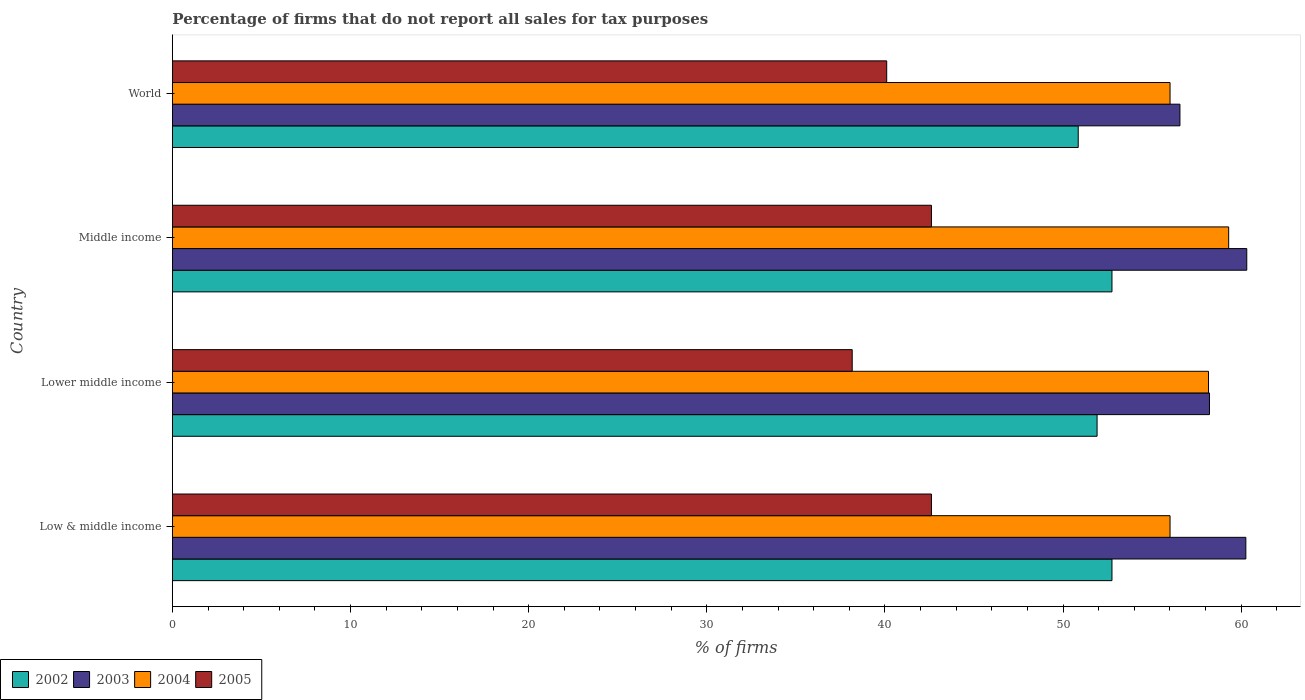How many groups of bars are there?
Offer a terse response. 4. Are the number of bars per tick equal to the number of legend labels?
Provide a short and direct response. Yes. Are the number of bars on each tick of the Y-axis equal?
Provide a short and direct response. Yes. What is the percentage of firms that do not report all sales for tax purposes in 2002 in Low & middle income?
Provide a succinct answer. 52.75. Across all countries, what is the maximum percentage of firms that do not report all sales for tax purposes in 2004?
Ensure brevity in your answer.  59.3. Across all countries, what is the minimum percentage of firms that do not report all sales for tax purposes in 2005?
Keep it short and to the point. 38.16. In which country was the percentage of firms that do not report all sales for tax purposes in 2002 maximum?
Offer a very short reply. Low & middle income. In which country was the percentage of firms that do not report all sales for tax purposes in 2003 minimum?
Give a very brief answer. World. What is the total percentage of firms that do not report all sales for tax purposes in 2002 in the graph?
Your answer should be very brief. 208.25. What is the difference between the percentage of firms that do not report all sales for tax purposes in 2005 in Middle income and that in World?
Your answer should be compact. 2.51. What is the difference between the percentage of firms that do not report all sales for tax purposes in 2003 in Middle income and the percentage of firms that do not report all sales for tax purposes in 2005 in World?
Ensure brevity in your answer.  20.21. What is the average percentage of firms that do not report all sales for tax purposes in 2003 per country?
Ensure brevity in your answer.  58.84. What is the difference between the percentage of firms that do not report all sales for tax purposes in 2003 and percentage of firms that do not report all sales for tax purposes in 2004 in World?
Offer a terse response. 0.55. What is the ratio of the percentage of firms that do not report all sales for tax purposes in 2004 in Low & middle income to that in Middle income?
Make the answer very short. 0.94. Is the difference between the percentage of firms that do not report all sales for tax purposes in 2003 in Low & middle income and Lower middle income greater than the difference between the percentage of firms that do not report all sales for tax purposes in 2004 in Low & middle income and Lower middle income?
Keep it short and to the point. Yes. What is the difference between the highest and the second highest percentage of firms that do not report all sales for tax purposes in 2003?
Provide a short and direct response. 0.05. What is the difference between the highest and the lowest percentage of firms that do not report all sales for tax purposes in 2003?
Provide a succinct answer. 3.75. Are all the bars in the graph horizontal?
Your answer should be compact. Yes. Are the values on the major ticks of X-axis written in scientific E-notation?
Your answer should be very brief. No. Does the graph contain grids?
Make the answer very short. No. Where does the legend appear in the graph?
Offer a very short reply. Bottom left. How are the legend labels stacked?
Provide a short and direct response. Horizontal. What is the title of the graph?
Offer a terse response. Percentage of firms that do not report all sales for tax purposes. What is the label or title of the X-axis?
Your response must be concise. % of firms. What is the % of firms of 2002 in Low & middle income?
Your answer should be compact. 52.75. What is the % of firms of 2003 in Low & middle income?
Ensure brevity in your answer.  60.26. What is the % of firms in 2004 in Low & middle income?
Your answer should be compact. 56.01. What is the % of firms in 2005 in Low & middle income?
Your answer should be compact. 42.61. What is the % of firms in 2002 in Lower middle income?
Your response must be concise. 51.91. What is the % of firms in 2003 in Lower middle income?
Provide a succinct answer. 58.22. What is the % of firms in 2004 in Lower middle income?
Your answer should be very brief. 58.16. What is the % of firms in 2005 in Lower middle income?
Offer a terse response. 38.16. What is the % of firms of 2002 in Middle income?
Your answer should be compact. 52.75. What is the % of firms of 2003 in Middle income?
Provide a short and direct response. 60.31. What is the % of firms in 2004 in Middle income?
Keep it short and to the point. 59.3. What is the % of firms in 2005 in Middle income?
Offer a terse response. 42.61. What is the % of firms in 2002 in World?
Offer a very short reply. 50.85. What is the % of firms of 2003 in World?
Offer a terse response. 56.56. What is the % of firms of 2004 in World?
Your response must be concise. 56.01. What is the % of firms of 2005 in World?
Your answer should be very brief. 40.1. Across all countries, what is the maximum % of firms of 2002?
Your answer should be very brief. 52.75. Across all countries, what is the maximum % of firms in 2003?
Your response must be concise. 60.31. Across all countries, what is the maximum % of firms of 2004?
Provide a succinct answer. 59.3. Across all countries, what is the maximum % of firms in 2005?
Ensure brevity in your answer.  42.61. Across all countries, what is the minimum % of firms in 2002?
Provide a short and direct response. 50.85. Across all countries, what is the minimum % of firms of 2003?
Your answer should be compact. 56.56. Across all countries, what is the minimum % of firms of 2004?
Offer a terse response. 56.01. Across all countries, what is the minimum % of firms of 2005?
Provide a short and direct response. 38.16. What is the total % of firms in 2002 in the graph?
Provide a short and direct response. 208.25. What is the total % of firms in 2003 in the graph?
Give a very brief answer. 235.35. What is the total % of firms of 2004 in the graph?
Provide a succinct answer. 229.47. What is the total % of firms in 2005 in the graph?
Your answer should be very brief. 163.48. What is the difference between the % of firms of 2002 in Low & middle income and that in Lower middle income?
Your response must be concise. 0.84. What is the difference between the % of firms of 2003 in Low & middle income and that in Lower middle income?
Ensure brevity in your answer.  2.04. What is the difference between the % of firms in 2004 in Low & middle income and that in Lower middle income?
Keep it short and to the point. -2.16. What is the difference between the % of firms in 2005 in Low & middle income and that in Lower middle income?
Ensure brevity in your answer.  4.45. What is the difference between the % of firms in 2003 in Low & middle income and that in Middle income?
Your answer should be compact. -0.05. What is the difference between the % of firms of 2004 in Low & middle income and that in Middle income?
Keep it short and to the point. -3.29. What is the difference between the % of firms of 2005 in Low & middle income and that in Middle income?
Your answer should be compact. 0. What is the difference between the % of firms in 2002 in Low & middle income and that in World?
Offer a very short reply. 1.89. What is the difference between the % of firms of 2003 in Low & middle income and that in World?
Keep it short and to the point. 3.7. What is the difference between the % of firms of 2004 in Low & middle income and that in World?
Offer a terse response. 0. What is the difference between the % of firms of 2005 in Low & middle income and that in World?
Your response must be concise. 2.51. What is the difference between the % of firms of 2002 in Lower middle income and that in Middle income?
Your response must be concise. -0.84. What is the difference between the % of firms of 2003 in Lower middle income and that in Middle income?
Offer a very short reply. -2.09. What is the difference between the % of firms of 2004 in Lower middle income and that in Middle income?
Provide a succinct answer. -1.13. What is the difference between the % of firms in 2005 in Lower middle income and that in Middle income?
Provide a short and direct response. -4.45. What is the difference between the % of firms of 2002 in Lower middle income and that in World?
Give a very brief answer. 1.06. What is the difference between the % of firms in 2003 in Lower middle income and that in World?
Give a very brief answer. 1.66. What is the difference between the % of firms in 2004 in Lower middle income and that in World?
Ensure brevity in your answer.  2.16. What is the difference between the % of firms in 2005 in Lower middle income and that in World?
Offer a terse response. -1.94. What is the difference between the % of firms of 2002 in Middle income and that in World?
Provide a short and direct response. 1.89. What is the difference between the % of firms of 2003 in Middle income and that in World?
Make the answer very short. 3.75. What is the difference between the % of firms of 2004 in Middle income and that in World?
Provide a short and direct response. 3.29. What is the difference between the % of firms in 2005 in Middle income and that in World?
Keep it short and to the point. 2.51. What is the difference between the % of firms of 2002 in Low & middle income and the % of firms of 2003 in Lower middle income?
Your response must be concise. -5.47. What is the difference between the % of firms in 2002 in Low & middle income and the % of firms in 2004 in Lower middle income?
Provide a succinct answer. -5.42. What is the difference between the % of firms in 2002 in Low & middle income and the % of firms in 2005 in Lower middle income?
Provide a short and direct response. 14.58. What is the difference between the % of firms in 2003 in Low & middle income and the % of firms in 2004 in Lower middle income?
Offer a very short reply. 2.1. What is the difference between the % of firms of 2003 in Low & middle income and the % of firms of 2005 in Lower middle income?
Offer a terse response. 22.1. What is the difference between the % of firms in 2004 in Low & middle income and the % of firms in 2005 in Lower middle income?
Provide a succinct answer. 17.84. What is the difference between the % of firms in 2002 in Low & middle income and the % of firms in 2003 in Middle income?
Keep it short and to the point. -7.57. What is the difference between the % of firms of 2002 in Low & middle income and the % of firms of 2004 in Middle income?
Keep it short and to the point. -6.55. What is the difference between the % of firms in 2002 in Low & middle income and the % of firms in 2005 in Middle income?
Offer a terse response. 10.13. What is the difference between the % of firms of 2003 in Low & middle income and the % of firms of 2005 in Middle income?
Ensure brevity in your answer.  17.65. What is the difference between the % of firms of 2004 in Low & middle income and the % of firms of 2005 in Middle income?
Your answer should be very brief. 13.39. What is the difference between the % of firms in 2002 in Low & middle income and the % of firms in 2003 in World?
Make the answer very short. -3.81. What is the difference between the % of firms in 2002 in Low & middle income and the % of firms in 2004 in World?
Provide a short and direct response. -3.26. What is the difference between the % of firms in 2002 in Low & middle income and the % of firms in 2005 in World?
Give a very brief answer. 12.65. What is the difference between the % of firms in 2003 in Low & middle income and the % of firms in 2004 in World?
Give a very brief answer. 4.25. What is the difference between the % of firms of 2003 in Low & middle income and the % of firms of 2005 in World?
Ensure brevity in your answer.  20.16. What is the difference between the % of firms of 2004 in Low & middle income and the % of firms of 2005 in World?
Ensure brevity in your answer.  15.91. What is the difference between the % of firms of 2002 in Lower middle income and the % of firms of 2003 in Middle income?
Keep it short and to the point. -8.4. What is the difference between the % of firms of 2002 in Lower middle income and the % of firms of 2004 in Middle income?
Provide a short and direct response. -7.39. What is the difference between the % of firms of 2002 in Lower middle income and the % of firms of 2005 in Middle income?
Provide a short and direct response. 9.3. What is the difference between the % of firms in 2003 in Lower middle income and the % of firms in 2004 in Middle income?
Keep it short and to the point. -1.08. What is the difference between the % of firms of 2003 in Lower middle income and the % of firms of 2005 in Middle income?
Offer a terse response. 15.61. What is the difference between the % of firms in 2004 in Lower middle income and the % of firms in 2005 in Middle income?
Offer a very short reply. 15.55. What is the difference between the % of firms in 2002 in Lower middle income and the % of firms in 2003 in World?
Provide a short and direct response. -4.65. What is the difference between the % of firms of 2002 in Lower middle income and the % of firms of 2004 in World?
Offer a very short reply. -4.1. What is the difference between the % of firms in 2002 in Lower middle income and the % of firms in 2005 in World?
Make the answer very short. 11.81. What is the difference between the % of firms of 2003 in Lower middle income and the % of firms of 2004 in World?
Provide a succinct answer. 2.21. What is the difference between the % of firms in 2003 in Lower middle income and the % of firms in 2005 in World?
Your answer should be very brief. 18.12. What is the difference between the % of firms in 2004 in Lower middle income and the % of firms in 2005 in World?
Offer a very short reply. 18.07. What is the difference between the % of firms of 2002 in Middle income and the % of firms of 2003 in World?
Offer a very short reply. -3.81. What is the difference between the % of firms of 2002 in Middle income and the % of firms of 2004 in World?
Your response must be concise. -3.26. What is the difference between the % of firms in 2002 in Middle income and the % of firms in 2005 in World?
Keep it short and to the point. 12.65. What is the difference between the % of firms of 2003 in Middle income and the % of firms of 2004 in World?
Your answer should be very brief. 4.31. What is the difference between the % of firms in 2003 in Middle income and the % of firms in 2005 in World?
Give a very brief answer. 20.21. What is the difference between the % of firms of 2004 in Middle income and the % of firms of 2005 in World?
Keep it short and to the point. 19.2. What is the average % of firms of 2002 per country?
Your response must be concise. 52.06. What is the average % of firms of 2003 per country?
Provide a succinct answer. 58.84. What is the average % of firms of 2004 per country?
Give a very brief answer. 57.37. What is the average % of firms in 2005 per country?
Give a very brief answer. 40.87. What is the difference between the % of firms of 2002 and % of firms of 2003 in Low & middle income?
Offer a very short reply. -7.51. What is the difference between the % of firms of 2002 and % of firms of 2004 in Low & middle income?
Offer a very short reply. -3.26. What is the difference between the % of firms of 2002 and % of firms of 2005 in Low & middle income?
Provide a short and direct response. 10.13. What is the difference between the % of firms of 2003 and % of firms of 2004 in Low & middle income?
Make the answer very short. 4.25. What is the difference between the % of firms in 2003 and % of firms in 2005 in Low & middle income?
Make the answer very short. 17.65. What is the difference between the % of firms in 2004 and % of firms in 2005 in Low & middle income?
Provide a short and direct response. 13.39. What is the difference between the % of firms of 2002 and % of firms of 2003 in Lower middle income?
Give a very brief answer. -6.31. What is the difference between the % of firms in 2002 and % of firms in 2004 in Lower middle income?
Your response must be concise. -6.26. What is the difference between the % of firms in 2002 and % of firms in 2005 in Lower middle income?
Your answer should be compact. 13.75. What is the difference between the % of firms in 2003 and % of firms in 2004 in Lower middle income?
Make the answer very short. 0.05. What is the difference between the % of firms of 2003 and % of firms of 2005 in Lower middle income?
Provide a short and direct response. 20.06. What is the difference between the % of firms in 2004 and % of firms in 2005 in Lower middle income?
Make the answer very short. 20. What is the difference between the % of firms of 2002 and % of firms of 2003 in Middle income?
Offer a terse response. -7.57. What is the difference between the % of firms of 2002 and % of firms of 2004 in Middle income?
Ensure brevity in your answer.  -6.55. What is the difference between the % of firms in 2002 and % of firms in 2005 in Middle income?
Provide a succinct answer. 10.13. What is the difference between the % of firms of 2003 and % of firms of 2004 in Middle income?
Provide a short and direct response. 1.02. What is the difference between the % of firms in 2003 and % of firms in 2005 in Middle income?
Your response must be concise. 17.7. What is the difference between the % of firms of 2004 and % of firms of 2005 in Middle income?
Offer a very short reply. 16.69. What is the difference between the % of firms in 2002 and % of firms in 2003 in World?
Ensure brevity in your answer.  -5.71. What is the difference between the % of firms of 2002 and % of firms of 2004 in World?
Your answer should be compact. -5.15. What is the difference between the % of firms of 2002 and % of firms of 2005 in World?
Your answer should be very brief. 10.75. What is the difference between the % of firms in 2003 and % of firms in 2004 in World?
Offer a very short reply. 0.56. What is the difference between the % of firms of 2003 and % of firms of 2005 in World?
Provide a short and direct response. 16.46. What is the difference between the % of firms in 2004 and % of firms in 2005 in World?
Your response must be concise. 15.91. What is the ratio of the % of firms in 2002 in Low & middle income to that in Lower middle income?
Provide a succinct answer. 1.02. What is the ratio of the % of firms in 2003 in Low & middle income to that in Lower middle income?
Offer a terse response. 1.04. What is the ratio of the % of firms in 2004 in Low & middle income to that in Lower middle income?
Provide a short and direct response. 0.96. What is the ratio of the % of firms of 2005 in Low & middle income to that in Lower middle income?
Give a very brief answer. 1.12. What is the ratio of the % of firms of 2002 in Low & middle income to that in Middle income?
Offer a very short reply. 1. What is the ratio of the % of firms of 2004 in Low & middle income to that in Middle income?
Provide a short and direct response. 0.94. What is the ratio of the % of firms of 2002 in Low & middle income to that in World?
Your response must be concise. 1.04. What is the ratio of the % of firms in 2003 in Low & middle income to that in World?
Make the answer very short. 1.07. What is the ratio of the % of firms of 2005 in Low & middle income to that in World?
Make the answer very short. 1.06. What is the ratio of the % of firms in 2002 in Lower middle income to that in Middle income?
Offer a terse response. 0.98. What is the ratio of the % of firms of 2003 in Lower middle income to that in Middle income?
Give a very brief answer. 0.97. What is the ratio of the % of firms of 2004 in Lower middle income to that in Middle income?
Your response must be concise. 0.98. What is the ratio of the % of firms in 2005 in Lower middle income to that in Middle income?
Your response must be concise. 0.9. What is the ratio of the % of firms of 2002 in Lower middle income to that in World?
Offer a very short reply. 1.02. What is the ratio of the % of firms of 2003 in Lower middle income to that in World?
Provide a succinct answer. 1.03. What is the ratio of the % of firms in 2004 in Lower middle income to that in World?
Give a very brief answer. 1.04. What is the ratio of the % of firms in 2005 in Lower middle income to that in World?
Your answer should be compact. 0.95. What is the ratio of the % of firms in 2002 in Middle income to that in World?
Make the answer very short. 1.04. What is the ratio of the % of firms in 2003 in Middle income to that in World?
Offer a terse response. 1.07. What is the ratio of the % of firms of 2004 in Middle income to that in World?
Offer a terse response. 1.06. What is the ratio of the % of firms of 2005 in Middle income to that in World?
Your answer should be compact. 1.06. What is the difference between the highest and the second highest % of firms in 2003?
Ensure brevity in your answer.  0.05. What is the difference between the highest and the second highest % of firms in 2004?
Provide a succinct answer. 1.13. What is the difference between the highest and the second highest % of firms of 2005?
Your response must be concise. 0. What is the difference between the highest and the lowest % of firms in 2002?
Your response must be concise. 1.89. What is the difference between the highest and the lowest % of firms of 2003?
Your answer should be very brief. 3.75. What is the difference between the highest and the lowest % of firms of 2004?
Ensure brevity in your answer.  3.29. What is the difference between the highest and the lowest % of firms of 2005?
Provide a short and direct response. 4.45. 